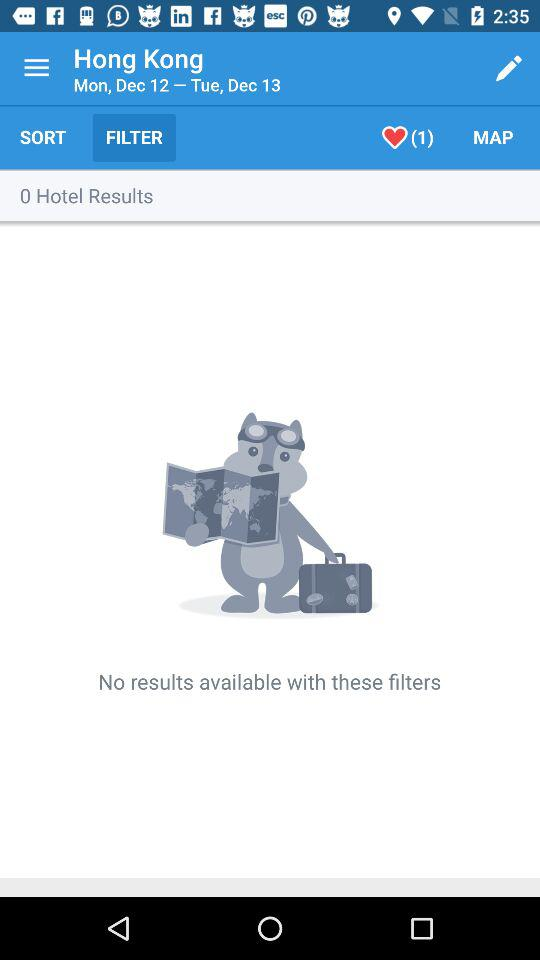What are the hotel results? There are no results available. 